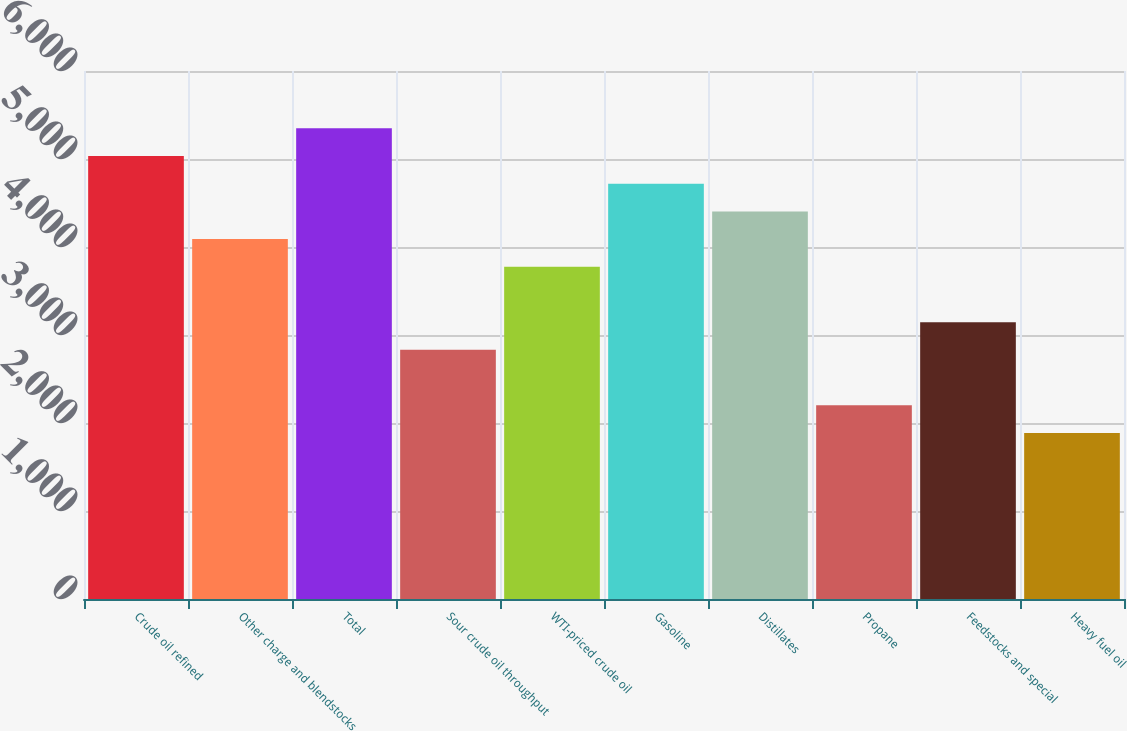<chart> <loc_0><loc_0><loc_500><loc_500><bar_chart><fcel>Crude oil refined<fcel>Other charge and blendstocks<fcel>Total<fcel>Sour crude oil throughput<fcel>WTI-priced crude oil<fcel>Gasoline<fcel>Distillates<fcel>Propane<fcel>Feedstocks and special<fcel>Heavy fuel oil<nl><fcel>5033.58<fcel>4089.81<fcel>5348.17<fcel>2831.45<fcel>3775.22<fcel>4718.99<fcel>4404.4<fcel>2202.27<fcel>3146.04<fcel>1887.68<nl></chart> 